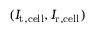Convert formula to latex. <formula><loc_0><loc_0><loc_500><loc_500>( I _ { t , c e l l } , I _ { r , c e l l } )</formula> 